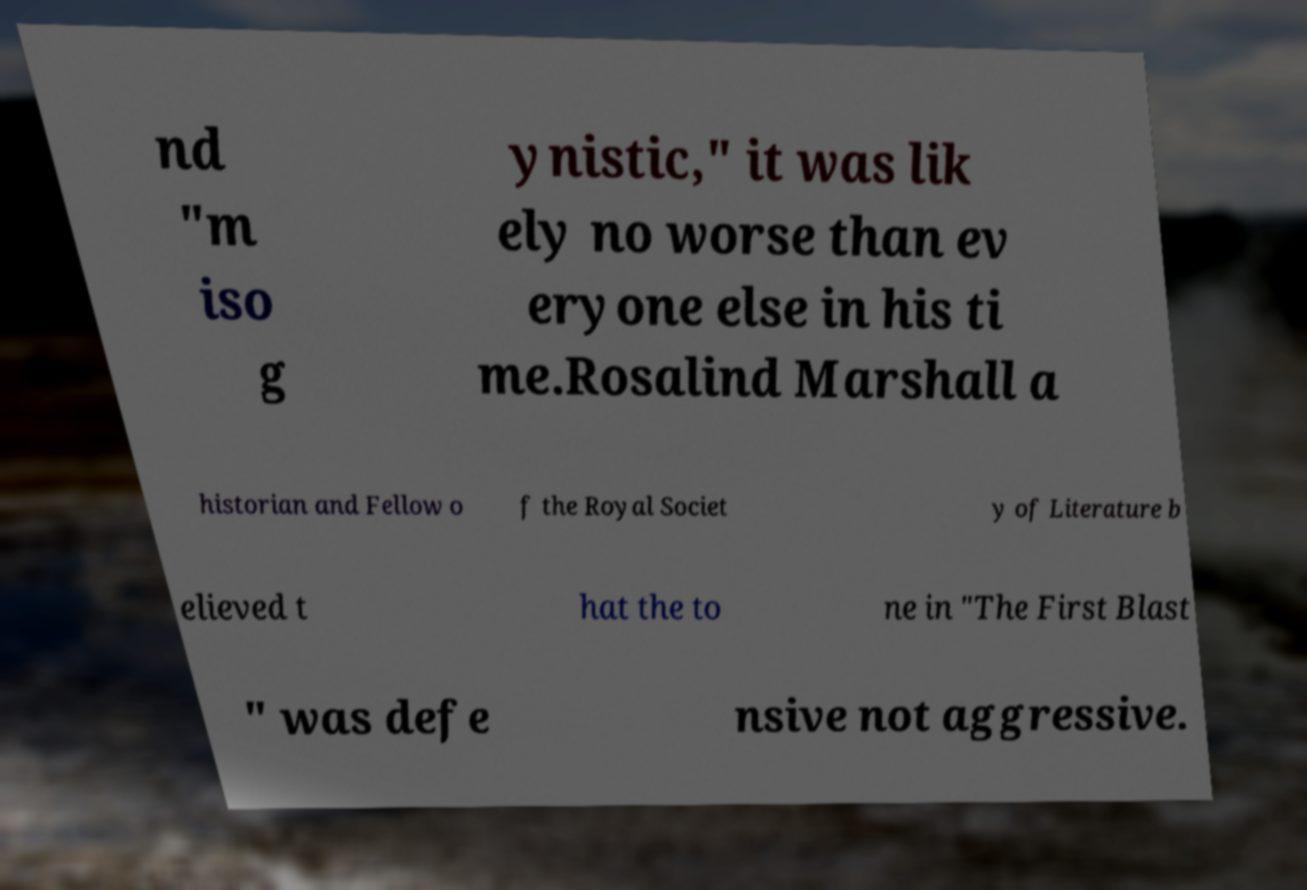There's text embedded in this image that I need extracted. Can you transcribe it verbatim? nd "m iso g ynistic," it was lik ely no worse than ev eryone else in his ti me.Rosalind Marshall a historian and Fellow o f the Royal Societ y of Literature b elieved t hat the to ne in "The First Blast " was defe nsive not aggressive. 